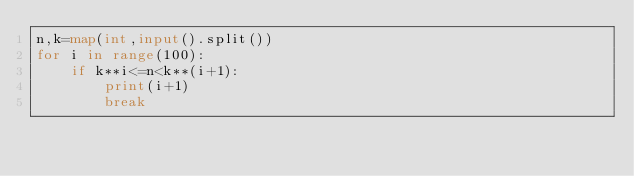<code> <loc_0><loc_0><loc_500><loc_500><_Python_>n,k=map(int,input().split())
for i in range(100):
    if k**i<=n<k**(i+1):
        print(i+1)
        break</code> 